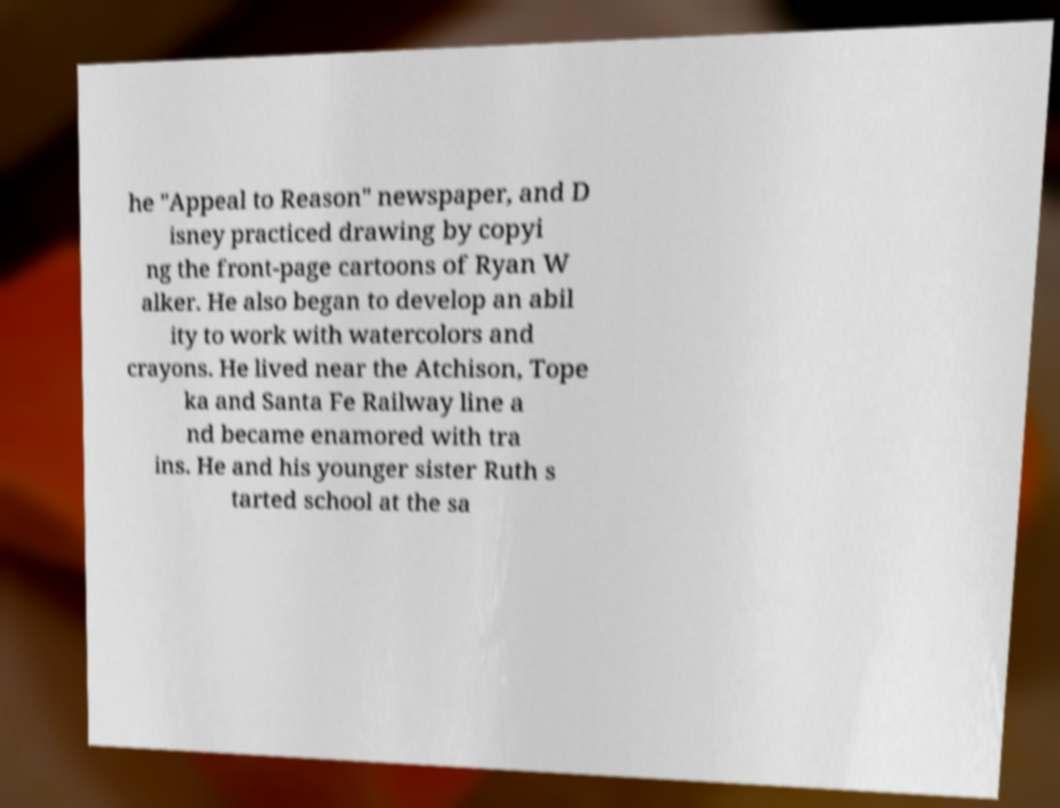I need the written content from this picture converted into text. Can you do that? he "Appeal to Reason" newspaper, and D isney practiced drawing by copyi ng the front-page cartoons of Ryan W alker. He also began to develop an abil ity to work with watercolors and crayons. He lived near the Atchison, Tope ka and Santa Fe Railway line a nd became enamored with tra ins. He and his younger sister Ruth s tarted school at the sa 